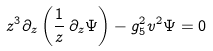Convert formula to latex. <formula><loc_0><loc_0><loc_500><loc_500>z ^ { 3 } \partial _ { z } \left ( \frac { 1 } { z } \, \partial _ { z } \Psi \right ) - g ^ { 2 } _ { 5 } v ^ { 2 } \Psi = 0</formula> 